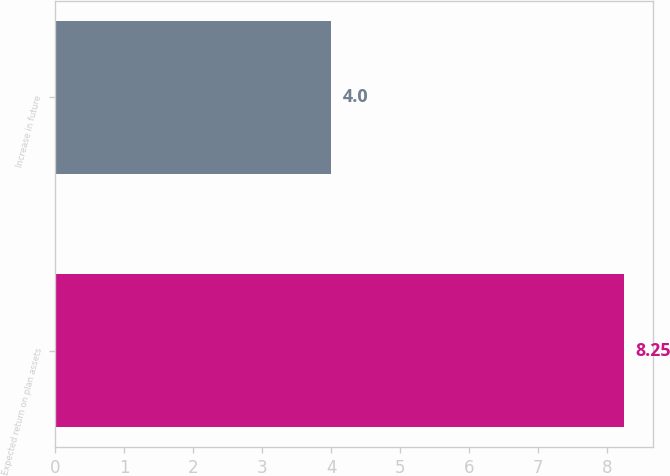Convert chart to OTSL. <chart><loc_0><loc_0><loc_500><loc_500><bar_chart><fcel>Expected return on plan assets<fcel>Increase in future<nl><fcel>8.25<fcel>4<nl></chart> 